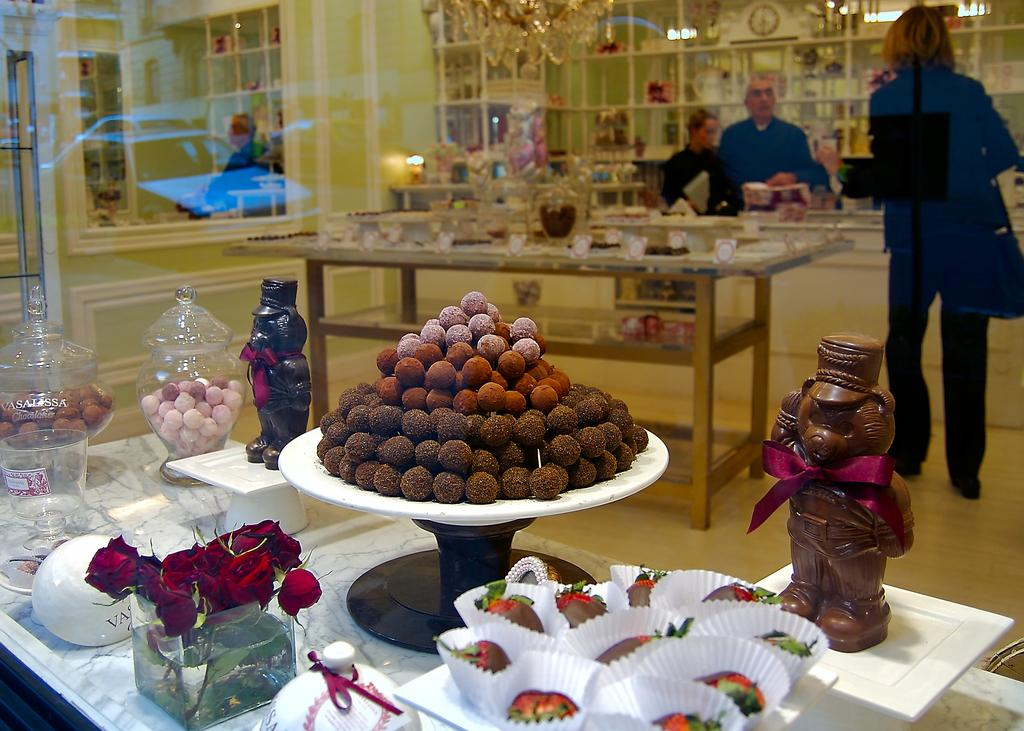What is the main subject of the image? The main subject of the image is a man. What is the man holding in his hand? The man is holding a mic in his hand. What type of support can be seen in the image? There is no support visible in the image; it only features a man holding a mic. Can you tell me how many tombstones are present in the image? There are no tombstones or cemetery present in the image; it only features a man holding a mic. 